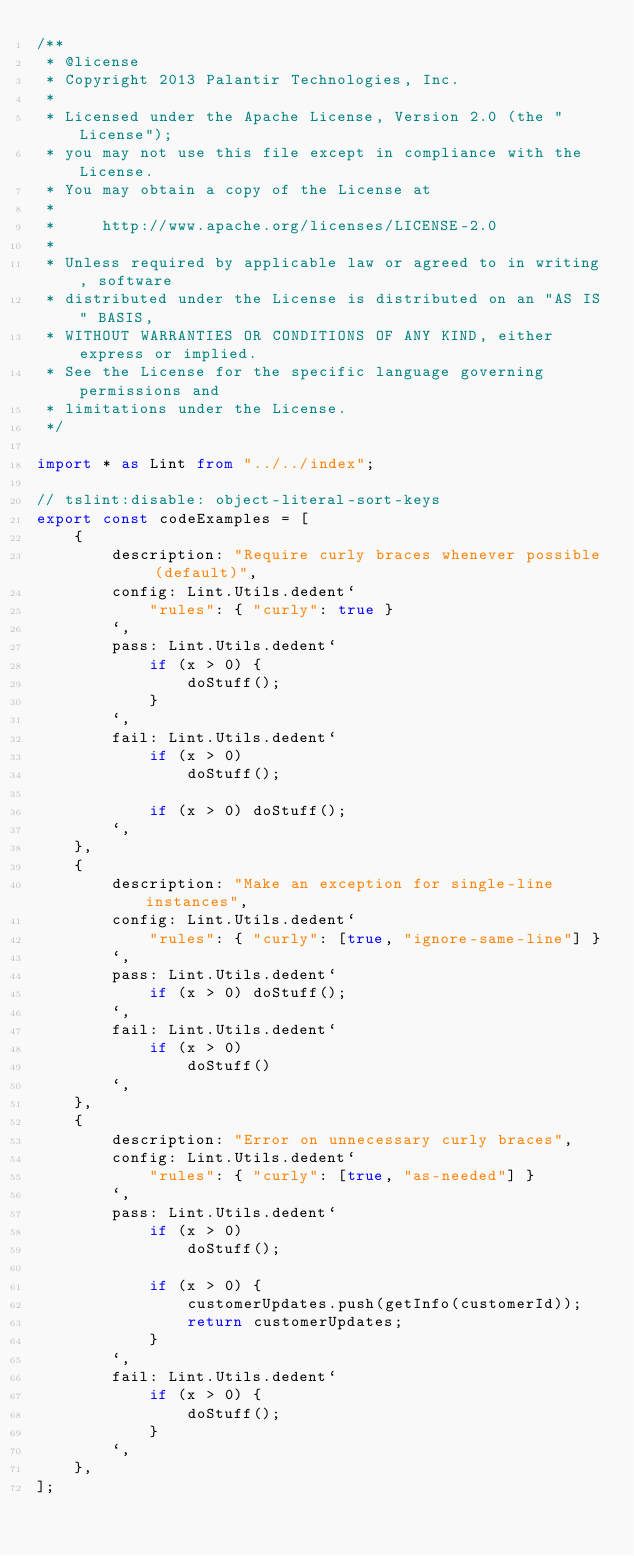Convert code to text. <code><loc_0><loc_0><loc_500><loc_500><_TypeScript_>/**
 * @license
 * Copyright 2013 Palantir Technologies, Inc.
 *
 * Licensed under the Apache License, Version 2.0 (the "License");
 * you may not use this file except in compliance with the License.
 * You may obtain a copy of the License at
 *
 *     http://www.apache.org/licenses/LICENSE-2.0
 *
 * Unless required by applicable law or agreed to in writing, software
 * distributed under the License is distributed on an "AS IS" BASIS,
 * WITHOUT WARRANTIES OR CONDITIONS OF ANY KIND, either express or implied.
 * See the License for the specific language governing permissions and
 * limitations under the License.
 */

import * as Lint from "../../index";

// tslint:disable: object-literal-sort-keys
export const codeExamples = [
    {
        description: "Require curly braces whenever possible (default)",
        config: Lint.Utils.dedent`
            "rules": { "curly": true }
        `,
        pass: Lint.Utils.dedent`
            if (x > 0) {
                doStuff();
            }
        `,
        fail: Lint.Utils.dedent`
            if (x > 0)
                doStuff();

            if (x > 0) doStuff();
        `,
    },
    {
        description: "Make an exception for single-line instances",
        config: Lint.Utils.dedent`
            "rules": { "curly": [true, "ignore-same-line"] }
        `,
        pass: Lint.Utils.dedent`
            if (x > 0) doStuff();
        `,
        fail: Lint.Utils.dedent`
            if (x > 0)
                doStuff()
        `,
    },
    {
        description: "Error on unnecessary curly braces",
        config: Lint.Utils.dedent`
            "rules": { "curly": [true, "as-needed"] }
        `,
        pass: Lint.Utils.dedent`
            if (x > 0)
                doStuff();

            if (x > 0) {
                customerUpdates.push(getInfo(customerId));
                return customerUpdates;
            }
        `,
        fail: Lint.Utils.dedent`
            if (x > 0) {
                doStuff();
            }
        `,
    },
];
</code> 